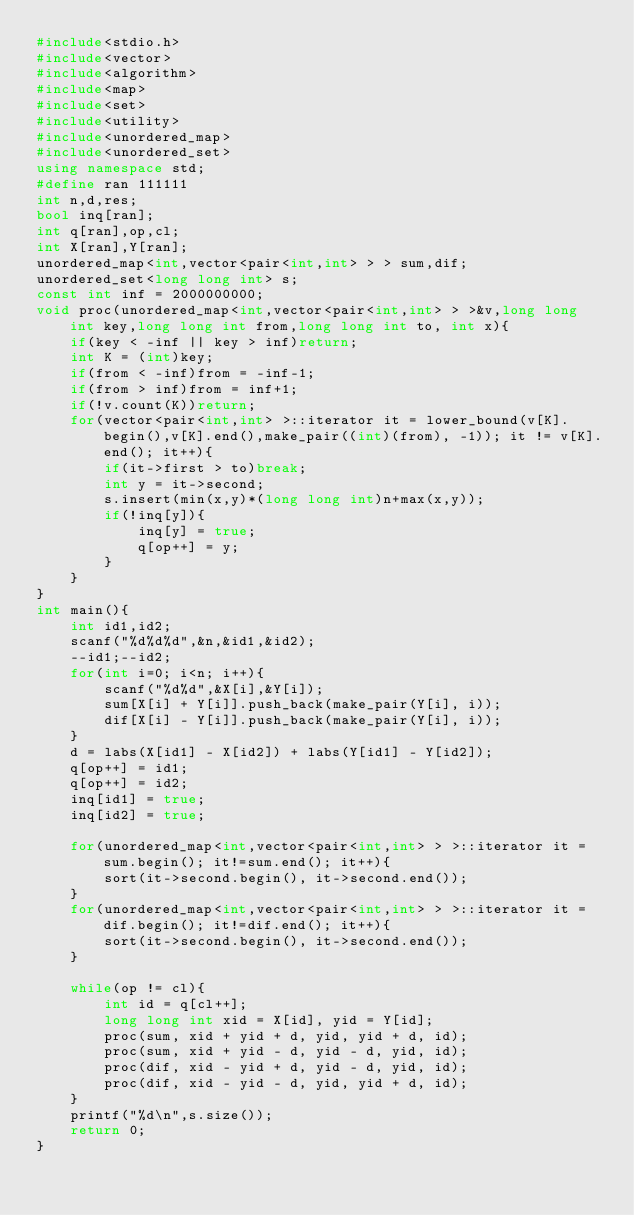Convert code to text. <code><loc_0><loc_0><loc_500><loc_500><_C++_>#include<stdio.h>
#include<vector>
#include<algorithm>
#include<map>
#include<set>
#include<utility>
#include<unordered_map>
#include<unordered_set>
using namespace std;
#define ran 111111
int n,d,res;
bool inq[ran];
int q[ran],op,cl;
int X[ran],Y[ran];
unordered_map<int,vector<pair<int,int> > > sum,dif;
unordered_set<long long int> s;
const int inf = 2000000000;
void proc(unordered_map<int,vector<pair<int,int> > >&v,long long int key,long long int from,long long int to, int x){
	if(key < -inf || key > inf)return;
	int K = (int)key;
	if(from < -inf)from = -inf-1;
	if(from > inf)from = inf+1;
	if(!v.count(K))return;
	for(vector<pair<int,int> >::iterator it = lower_bound(v[K].begin(),v[K].end(),make_pair((int)(from), -1)); it != v[K].end(); it++){
		if(it->first > to)break;
		int y = it->second;
		s.insert(min(x,y)*(long long int)n+max(x,y));
		if(!inq[y]){
			inq[y] = true;
			q[op++] = y;
		}
	}
}
int main(){
	int id1,id2;
	scanf("%d%d%d",&n,&id1,&id2);
	--id1;--id2;
	for(int i=0; i<n; i++){
		scanf("%d%d",&X[i],&Y[i]);
		sum[X[i] + Y[i]].push_back(make_pair(Y[i], i));
		dif[X[i] - Y[i]].push_back(make_pair(Y[i], i));
	}
	d = labs(X[id1] - X[id2]) + labs(Y[id1] - Y[id2]);
	q[op++] = id1;
	q[op++] = id2;
	inq[id1] = true;
	inq[id2] = true;

	for(unordered_map<int,vector<pair<int,int> > >::iterator it = sum.begin(); it!=sum.end(); it++){
		sort(it->second.begin(), it->second.end());
	}
	for(unordered_map<int,vector<pair<int,int> > >::iterator it = dif.begin(); it!=dif.end(); it++){
		sort(it->second.begin(), it->second.end());
	}

	while(op != cl){
		int id = q[cl++];
		long long int xid = X[id], yid = Y[id];
		proc(sum, xid + yid + d, yid, yid + d, id);
		proc(sum, xid + yid - d, yid - d, yid, id);
		proc(dif, xid - yid + d, yid - d, yid, id);
		proc(dif, xid - yid - d, yid, yid + d, id);
	}
	printf("%d\n",s.size());
	return 0;
}
</code> 